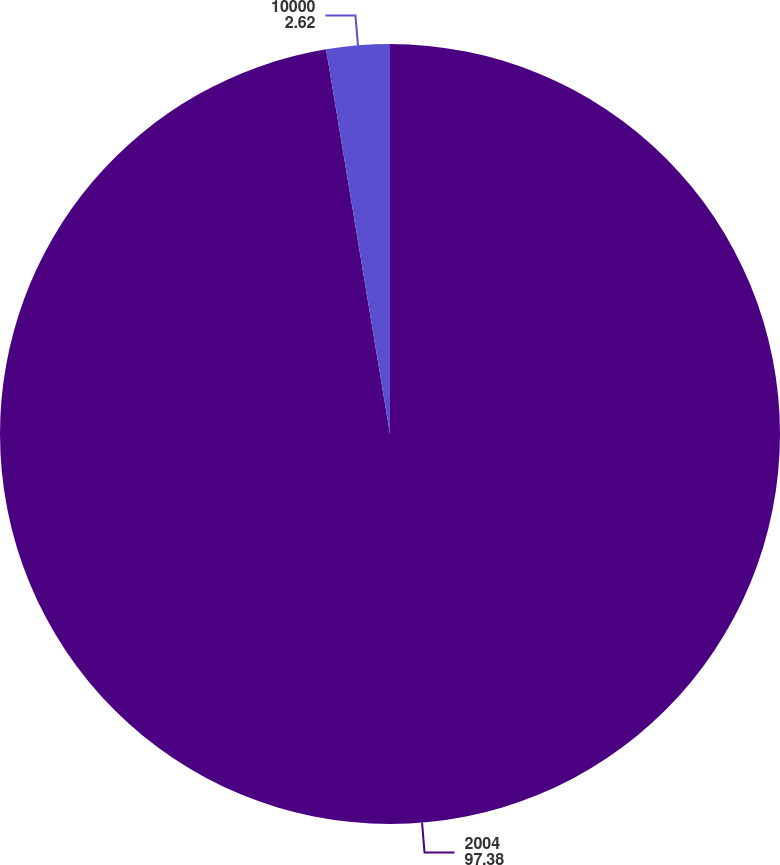<chart> <loc_0><loc_0><loc_500><loc_500><pie_chart><fcel>2004<fcel>10000<nl><fcel>97.38%<fcel>2.62%<nl></chart> 